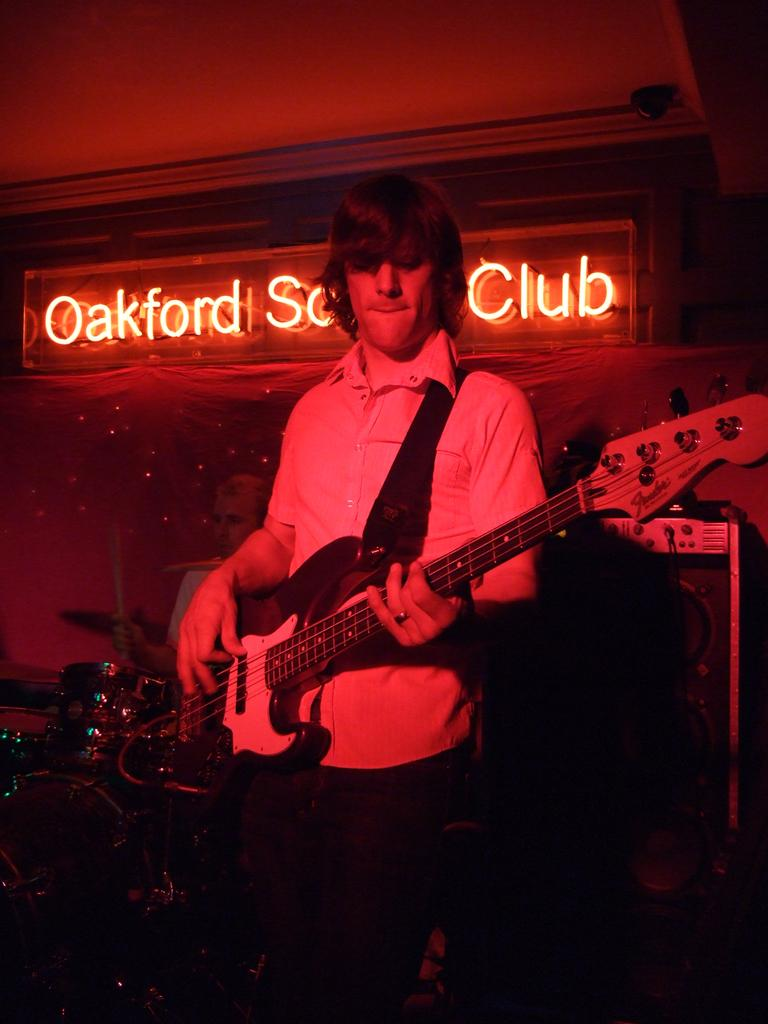What is the man in the image doing? The man is playing a guitar in the image. What other objects related to music can be seen in the image? There are musical instruments visible in the image. What type of signage is present in the image? There is a hoarding in the image. What type of pen is the man using to write on the mint in the image? There is no pen or mint present in the image; the man is playing a guitar and there is a hoarding visible. 